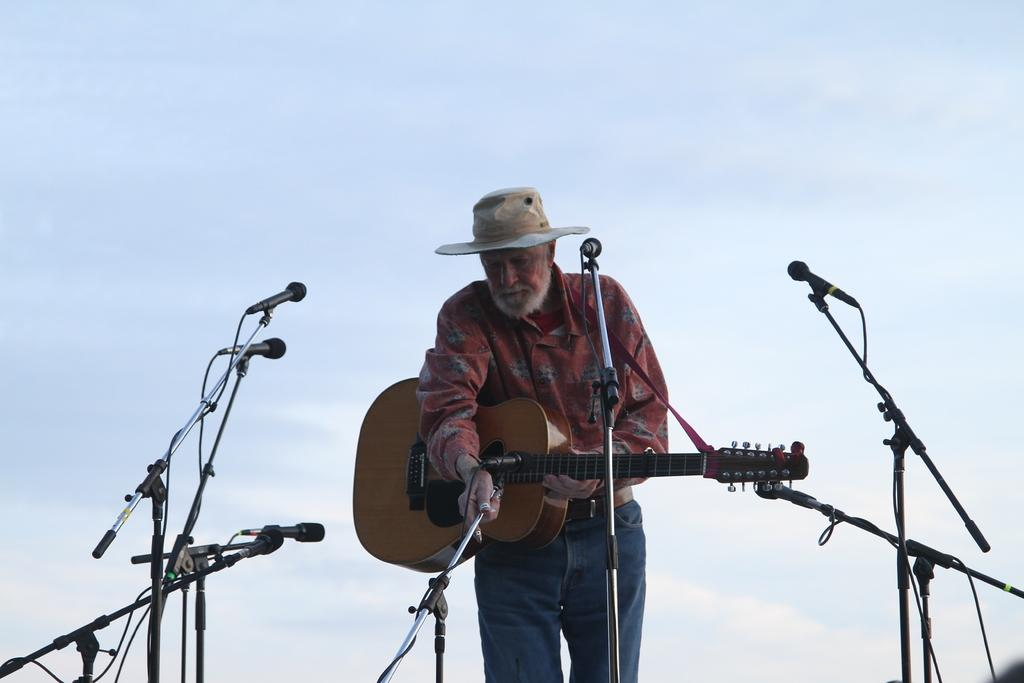What is the main subject of the image? There is a person in the image. What is the person doing in the image? The person is standing and holding a guitar. What is the person wearing in the image? The person is wearing a hat. What objects are around the person in the image? There are multiple microphones around the person. What type of zinc can be seen in the image? There is no zinc present in the image. How many songs is the person singing in the image? The image does not show the person singing, so it cannot be determined how many songs they might be singing. 